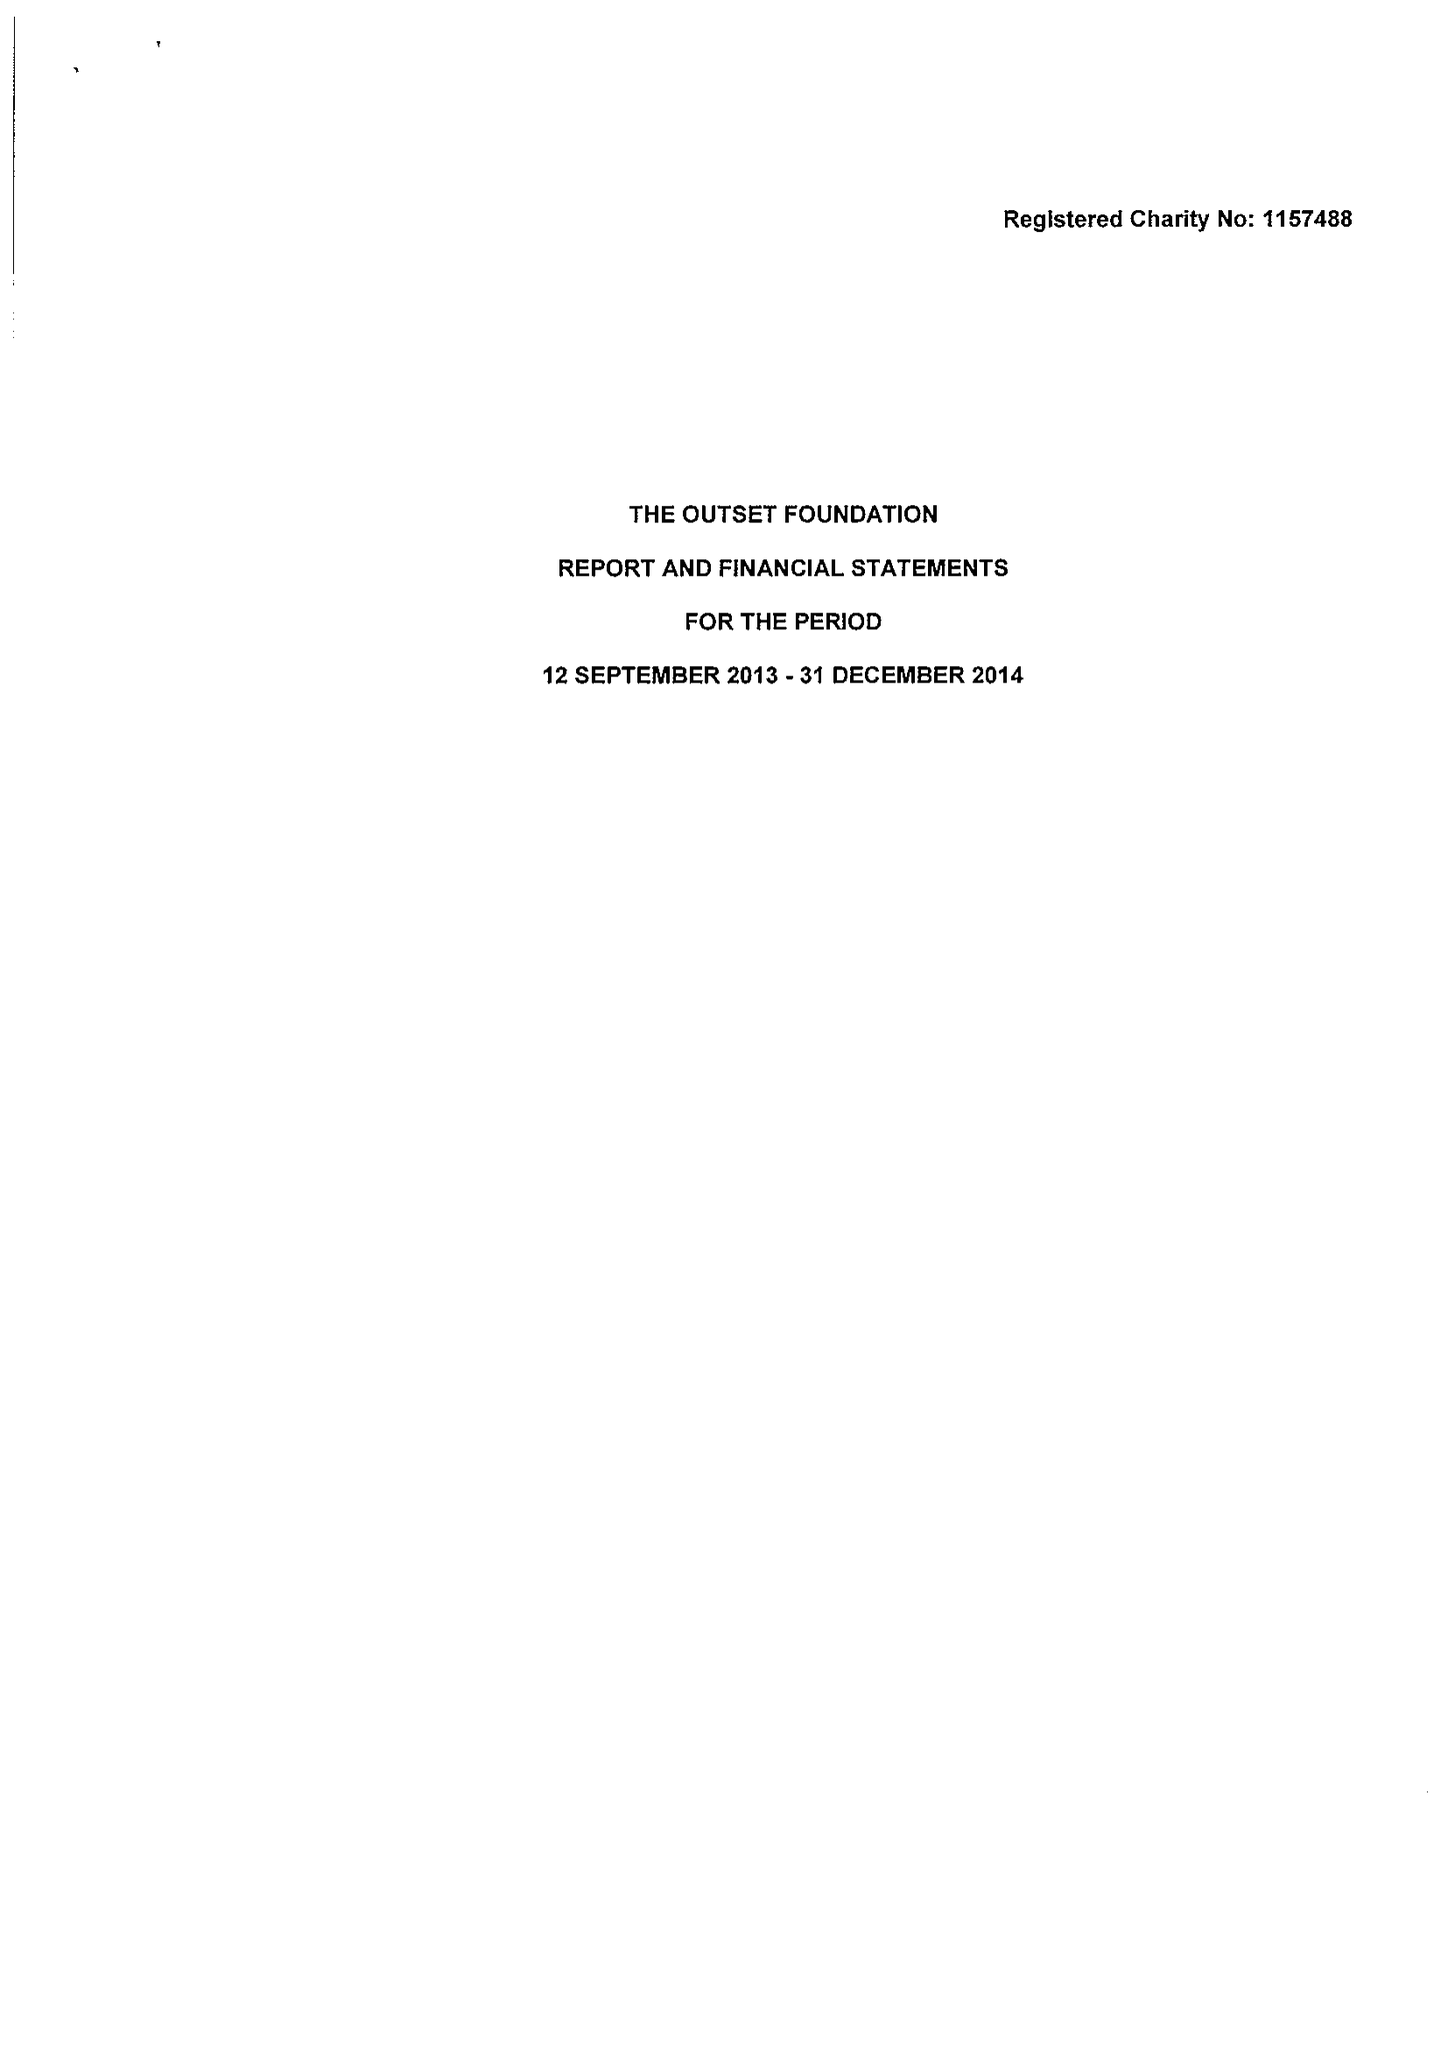What is the value for the income_annually_in_british_pounds?
Answer the question using a single word or phrase. 432020.00 